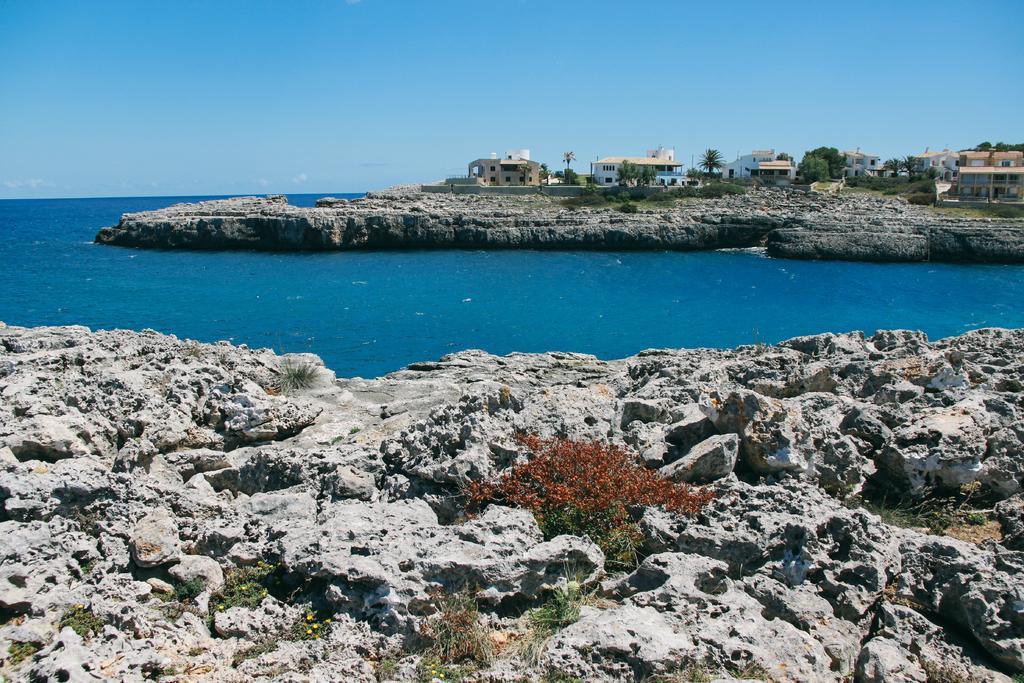How would you summarize this image in a sentence or two? In this picture I can observe an ocean. There are houses on the right side. In the background there is sky. 